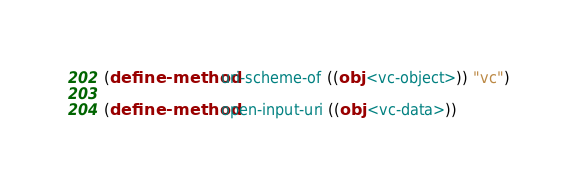<code> <loc_0><loc_0><loc_500><loc_500><_Scheme_>(define-method uri-scheme-of ((obj <vc-object>)) "vc")

(define-method open-input-uri ((obj <vc-data>))</code> 